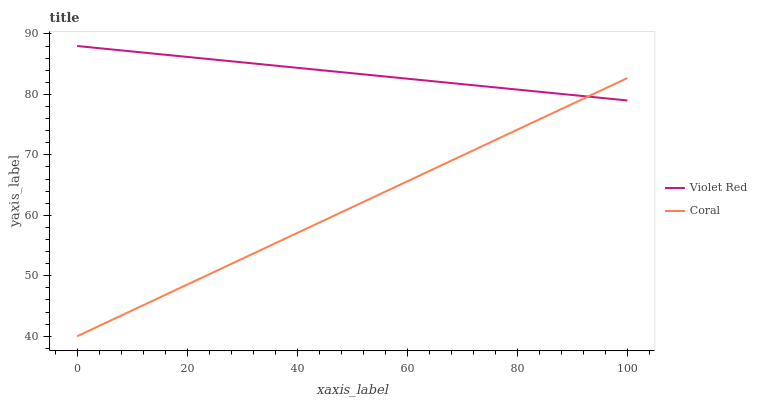Does Coral have the minimum area under the curve?
Answer yes or no. Yes. Does Violet Red have the maximum area under the curve?
Answer yes or no. Yes. Does Coral have the maximum area under the curve?
Answer yes or no. No. Is Coral the smoothest?
Answer yes or no. Yes. Is Violet Red the roughest?
Answer yes or no. Yes. Is Coral the roughest?
Answer yes or no. No. Does Coral have the lowest value?
Answer yes or no. Yes. Does Violet Red have the highest value?
Answer yes or no. Yes. Does Coral have the highest value?
Answer yes or no. No. Does Coral intersect Violet Red?
Answer yes or no. Yes. Is Coral less than Violet Red?
Answer yes or no. No. Is Coral greater than Violet Red?
Answer yes or no. No. 